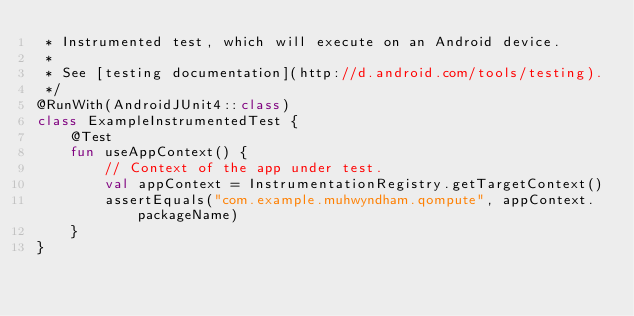<code> <loc_0><loc_0><loc_500><loc_500><_Kotlin_> * Instrumented test, which will execute on an Android device.
 *
 * See [testing documentation](http://d.android.com/tools/testing).
 */
@RunWith(AndroidJUnit4::class)
class ExampleInstrumentedTest {
    @Test
    fun useAppContext() {
        // Context of the app under test.
        val appContext = InstrumentationRegistry.getTargetContext()
        assertEquals("com.example.muhwyndham.qompute", appContext.packageName)
    }
}
</code> 